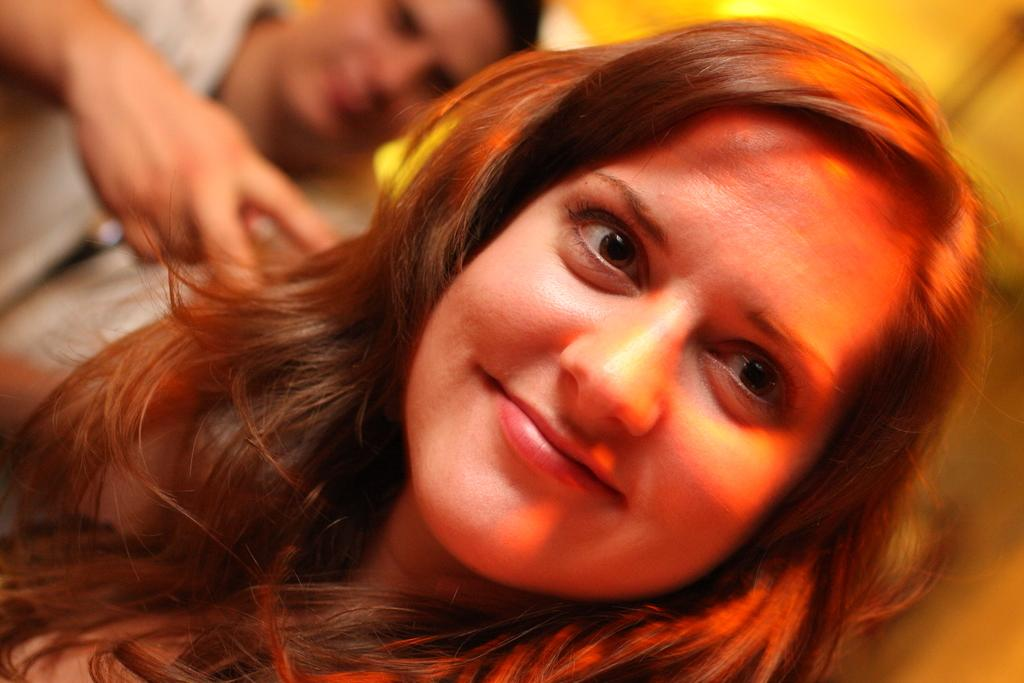What is the main subject of the image? There is a woman in the image. Can you describe the woman's appearance? The woman has red hair. Is there anyone else in the image besides the woman? Yes, there is a person behind the woman in the image. What type of toothpaste is the woman using in the image? There is no toothpaste present in the image, as it features a woman with red hair and another person behind her. 